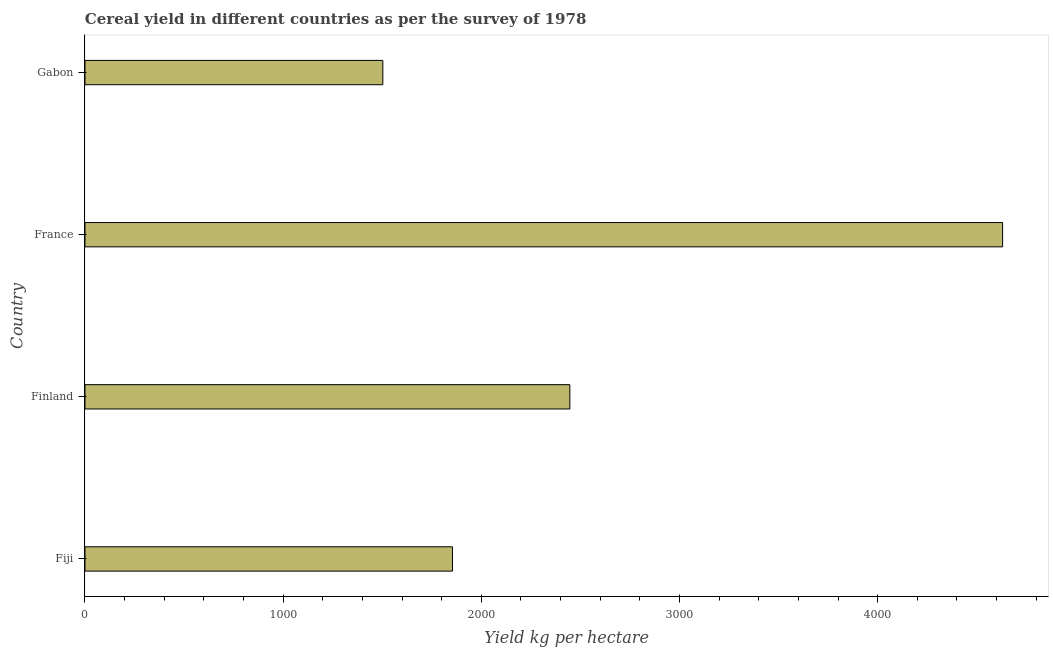Does the graph contain any zero values?
Give a very brief answer. No. What is the title of the graph?
Make the answer very short. Cereal yield in different countries as per the survey of 1978. What is the label or title of the X-axis?
Ensure brevity in your answer.  Yield kg per hectare. What is the cereal yield in Fiji?
Give a very brief answer. 1854.4. Across all countries, what is the maximum cereal yield?
Your answer should be very brief. 4630.46. Across all countries, what is the minimum cereal yield?
Offer a terse response. 1503.04. In which country was the cereal yield minimum?
Offer a very short reply. Gabon. What is the sum of the cereal yield?
Keep it short and to the point. 1.04e+04. What is the difference between the cereal yield in France and Gabon?
Give a very brief answer. 3127.42. What is the average cereal yield per country?
Give a very brief answer. 2608.64. What is the median cereal yield?
Your answer should be compact. 2150.53. In how many countries, is the cereal yield greater than 3800 kg per hectare?
Give a very brief answer. 1. What is the ratio of the cereal yield in Fiji to that in France?
Provide a short and direct response. 0.4. Is the cereal yield in Finland less than that in France?
Offer a very short reply. Yes. Is the difference between the cereal yield in France and Gabon greater than the difference between any two countries?
Offer a terse response. Yes. What is the difference between the highest and the second highest cereal yield?
Offer a very short reply. 2183.8. What is the difference between the highest and the lowest cereal yield?
Make the answer very short. 3127.42. In how many countries, is the cereal yield greater than the average cereal yield taken over all countries?
Give a very brief answer. 1. How many countries are there in the graph?
Ensure brevity in your answer.  4. What is the difference between two consecutive major ticks on the X-axis?
Provide a short and direct response. 1000. Are the values on the major ticks of X-axis written in scientific E-notation?
Give a very brief answer. No. What is the Yield kg per hectare of Fiji?
Offer a very short reply. 1854.4. What is the Yield kg per hectare of Finland?
Your answer should be compact. 2446.66. What is the Yield kg per hectare in France?
Keep it short and to the point. 4630.46. What is the Yield kg per hectare of Gabon?
Your answer should be very brief. 1503.04. What is the difference between the Yield kg per hectare in Fiji and Finland?
Provide a succinct answer. -592.26. What is the difference between the Yield kg per hectare in Fiji and France?
Your answer should be compact. -2776.06. What is the difference between the Yield kg per hectare in Fiji and Gabon?
Offer a very short reply. 351.36. What is the difference between the Yield kg per hectare in Finland and France?
Your response must be concise. -2183.8. What is the difference between the Yield kg per hectare in Finland and Gabon?
Ensure brevity in your answer.  943.62. What is the difference between the Yield kg per hectare in France and Gabon?
Keep it short and to the point. 3127.42. What is the ratio of the Yield kg per hectare in Fiji to that in Finland?
Keep it short and to the point. 0.76. What is the ratio of the Yield kg per hectare in Fiji to that in France?
Make the answer very short. 0.4. What is the ratio of the Yield kg per hectare in Fiji to that in Gabon?
Make the answer very short. 1.23. What is the ratio of the Yield kg per hectare in Finland to that in France?
Provide a succinct answer. 0.53. What is the ratio of the Yield kg per hectare in Finland to that in Gabon?
Your answer should be compact. 1.63. What is the ratio of the Yield kg per hectare in France to that in Gabon?
Give a very brief answer. 3.08. 